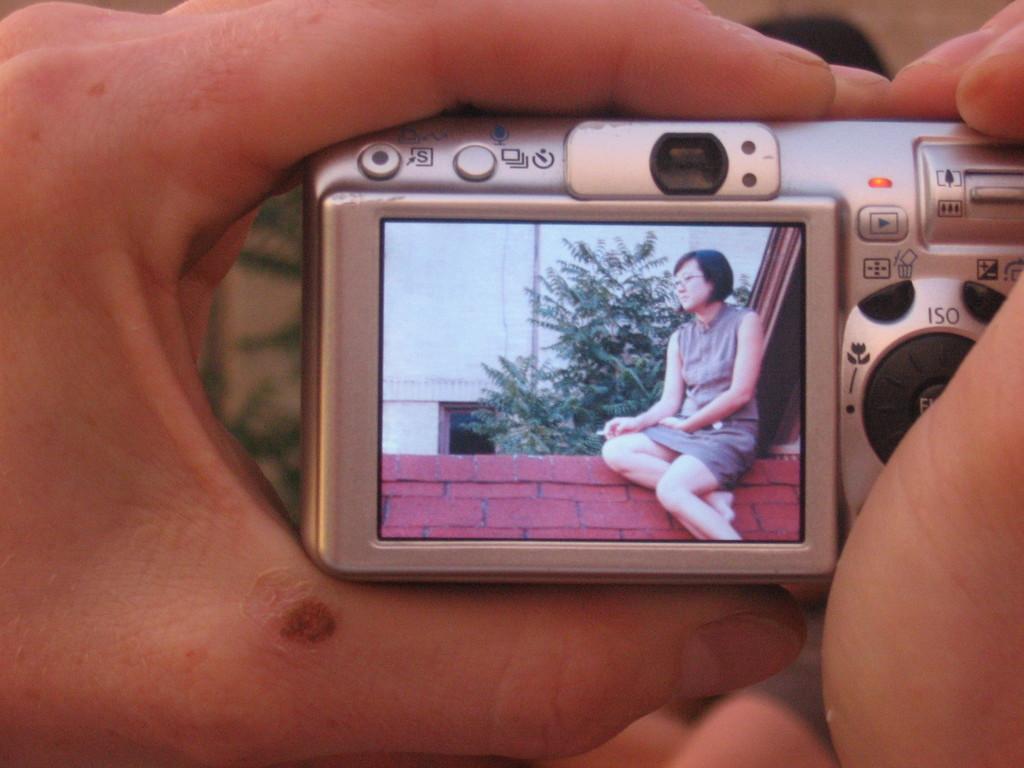What number setting is the camera on?
Keep it short and to the point. Unanswerable. What are the three letters above the black circle on the right?
Ensure brevity in your answer.  Iso. 